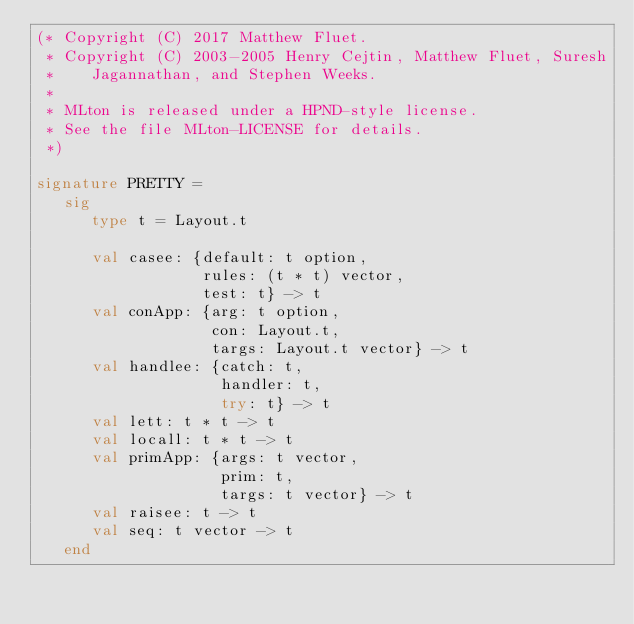Convert code to text. <code><loc_0><loc_0><loc_500><loc_500><_SML_>(* Copyright (C) 2017 Matthew Fluet.
 * Copyright (C) 2003-2005 Henry Cejtin, Matthew Fluet, Suresh
 *    Jagannathan, and Stephen Weeks.
 *
 * MLton is released under a HPND-style license.
 * See the file MLton-LICENSE for details.
 *)

signature PRETTY =
   sig
      type t = Layout.t

      val casee: {default: t option,
                  rules: (t * t) vector,
                  test: t} -> t
      val conApp: {arg: t option,
                   con: Layout.t,
                   targs: Layout.t vector} -> t
      val handlee: {catch: t,
                    handler: t,
                    try: t} -> t
      val lett: t * t -> t
      val locall: t * t -> t
      val primApp: {args: t vector,
                    prim: t,
                    targs: t vector} -> t
      val raisee: t -> t
      val seq: t vector -> t
   end
</code> 